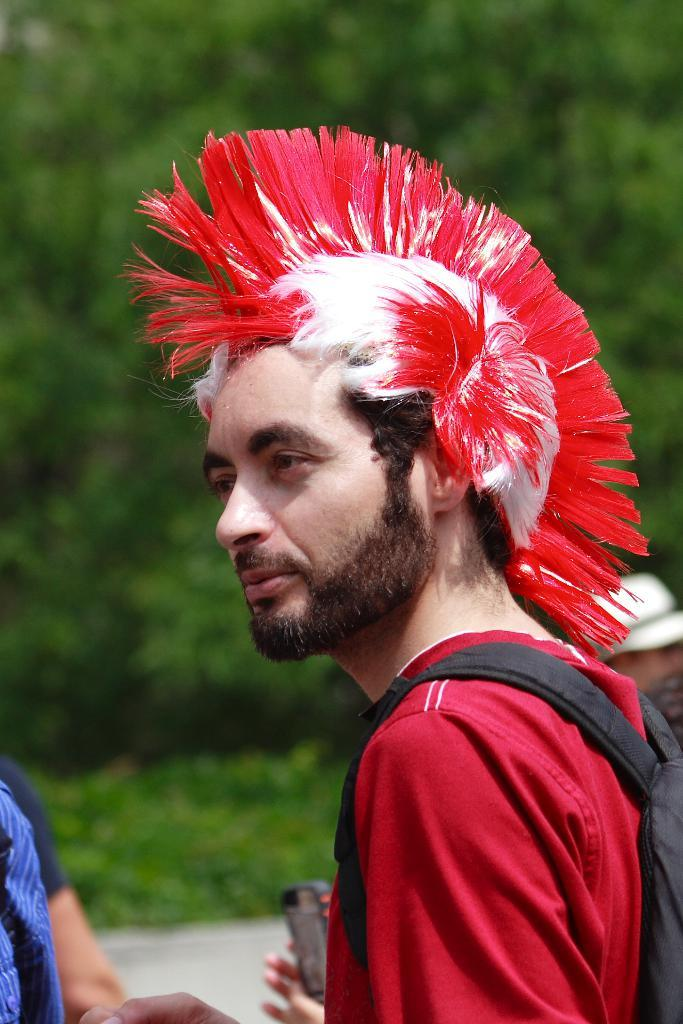Where is the first person located in the image? There is a person in the left corner of the image. Where are the other people located in the image? There are people in the right corner of the image. Can you describe the clothing of one of the people in the image? There is a person wearing a bag in the image. What can be seen in the background of the image? There are trees in the background of the image. What type of instrument is the person in the left corner playing in the image? There is no instrument present in the image, and the person in the left corner is not playing any instrument. 